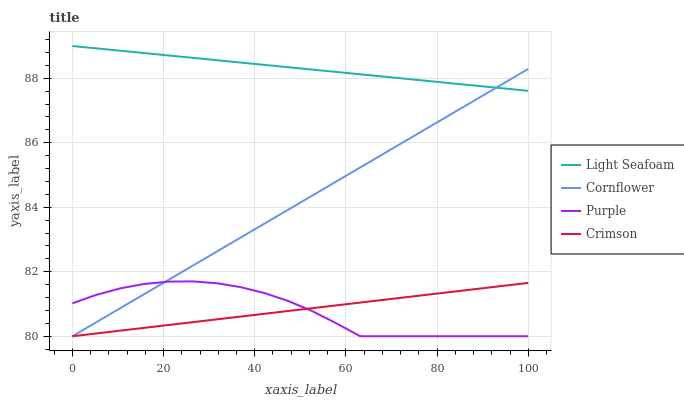Does Cornflower have the minimum area under the curve?
Answer yes or no. No. Does Cornflower have the maximum area under the curve?
Answer yes or no. No. Is Cornflower the smoothest?
Answer yes or no. No. Is Cornflower the roughest?
Answer yes or no. No. Does Light Seafoam have the lowest value?
Answer yes or no. No. Does Cornflower have the highest value?
Answer yes or no. No. Is Crimson less than Light Seafoam?
Answer yes or no. Yes. Is Light Seafoam greater than Crimson?
Answer yes or no. Yes. Does Crimson intersect Light Seafoam?
Answer yes or no. No. 